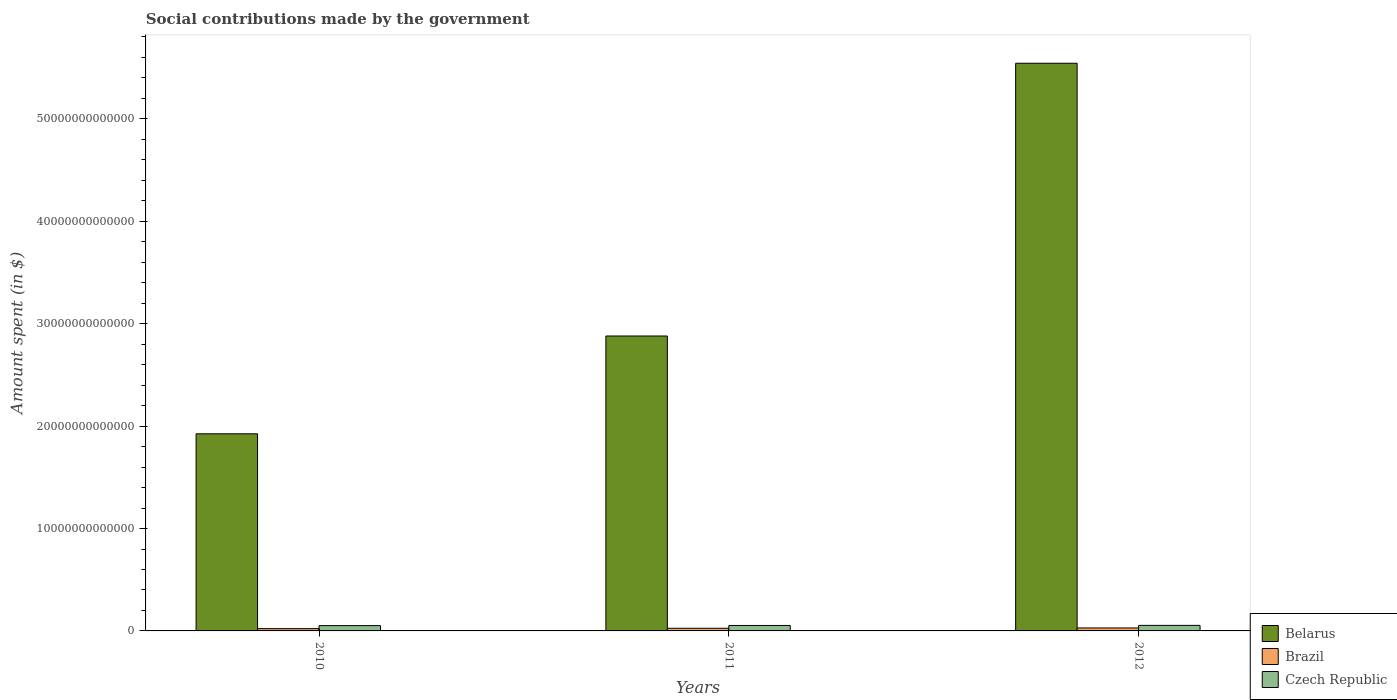How many different coloured bars are there?
Provide a succinct answer. 3. Are the number of bars per tick equal to the number of legend labels?
Keep it short and to the point. Yes. How many bars are there on the 3rd tick from the right?
Give a very brief answer. 3. What is the label of the 3rd group of bars from the left?
Offer a terse response. 2012. In how many cases, is the number of bars for a given year not equal to the number of legend labels?
Your answer should be very brief. 0. What is the amount spent on social contributions in Czech Republic in 2010?
Keep it short and to the point. 5.17e+11. Across all years, what is the maximum amount spent on social contributions in Brazil?
Your answer should be compact. 2.89e+11. Across all years, what is the minimum amount spent on social contributions in Brazil?
Provide a short and direct response. 2.24e+11. In which year was the amount spent on social contributions in Czech Republic minimum?
Offer a very short reply. 2010. What is the total amount spent on social contributions in Czech Republic in the graph?
Offer a terse response. 1.59e+12. What is the difference between the amount spent on social contributions in Belarus in 2010 and that in 2012?
Give a very brief answer. -3.62e+13. What is the difference between the amount spent on social contributions in Czech Republic in 2011 and the amount spent on social contributions in Brazil in 2012?
Provide a succinct answer. 2.44e+11. What is the average amount spent on social contributions in Brazil per year?
Provide a succinct answer. 2.58e+11. In the year 2012, what is the difference between the amount spent on social contributions in Brazil and amount spent on social contributions in Belarus?
Make the answer very short. -5.51e+13. In how many years, is the amount spent on social contributions in Brazil greater than 12000000000000 $?
Your answer should be compact. 0. What is the ratio of the amount spent on social contributions in Brazil in 2010 to that in 2012?
Ensure brevity in your answer.  0.77. What is the difference between the highest and the second highest amount spent on social contributions in Belarus?
Make the answer very short. 2.66e+13. What is the difference between the highest and the lowest amount spent on social contributions in Brazil?
Offer a terse response. 6.52e+1. In how many years, is the amount spent on social contributions in Brazil greater than the average amount spent on social contributions in Brazil taken over all years?
Provide a short and direct response. 2. Is the sum of the amount spent on social contributions in Brazil in 2010 and 2011 greater than the maximum amount spent on social contributions in Czech Republic across all years?
Offer a very short reply. No. What does the 1st bar from the left in 2011 represents?
Offer a terse response. Belarus. How many bars are there?
Your answer should be compact. 9. Are all the bars in the graph horizontal?
Provide a succinct answer. No. What is the difference between two consecutive major ticks on the Y-axis?
Keep it short and to the point. 1.00e+13. Are the values on the major ticks of Y-axis written in scientific E-notation?
Provide a short and direct response. No. Does the graph contain grids?
Your answer should be compact. No. How many legend labels are there?
Your answer should be very brief. 3. How are the legend labels stacked?
Offer a terse response. Vertical. What is the title of the graph?
Provide a succinct answer. Social contributions made by the government. What is the label or title of the Y-axis?
Your response must be concise. Amount spent (in $). What is the Amount spent (in $) in Belarus in 2010?
Your answer should be compact. 1.92e+13. What is the Amount spent (in $) in Brazil in 2010?
Give a very brief answer. 2.24e+11. What is the Amount spent (in $) in Czech Republic in 2010?
Give a very brief answer. 5.17e+11. What is the Amount spent (in $) in Belarus in 2011?
Provide a short and direct response. 2.88e+13. What is the Amount spent (in $) of Brazil in 2011?
Your response must be concise. 2.59e+11. What is the Amount spent (in $) in Czech Republic in 2011?
Provide a short and direct response. 5.33e+11. What is the Amount spent (in $) of Belarus in 2012?
Your answer should be very brief. 5.54e+13. What is the Amount spent (in $) in Brazil in 2012?
Give a very brief answer. 2.89e+11. What is the Amount spent (in $) of Czech Republic in 2012?
Provide a succinct answer. 5.41e+11. Across all years, what is the maximum Amount spent (in $) in Belarus?
Your answer should be very brief. 5.54e+13. Across all years, what is the maximum Amount spent (in $) in Brazil?
Give a very brief answer. 2.89e+11. Across all years, what is the maximum Amount spent (in $) in Czech Republic?
Give a very brief answer. 5.41e+11. Across all years, what is the minimum Amount spent (in $) in Belarus?
Keep it short and to the point. 1.92e+13. Across all years, what is the minimum Amount spent (in $) in Brazil?
Provide a succinct answer. 2.24e+11. Across all years, what is the minimum Amount spent (in $) of Czech Republic?
Make the answer very short. 5.17e+11. What is the total Amount spent (in $) in Belarus in the graph?
Offer a very short reply. 1.03e+14. What is the total Amount spent (in $) in Brazil in the graph?
Provide a short and direct response. 7.73e+11. What is the total Amount spent (in $) of Czech Republic in the graph?
Provide a succinct answer. 1.59e+12. What is the difference between the Amount spent (in $) in Belarus in 2010 and that in 2011?
Your response must be concise. -9.55e+12. What is the difference between the Amount spent (in $) in Brazil in 2010 and that in 2011?
Offer a terse response. -3.50e+1. What is the difference between the Amount spent (in $) in Czech Republic in 2010 and that in 2011?
Ensure brevity in your answer.  -1.57e+1. What is the difference between the Amount spent (in $) of Belarus in 2010 and that in 2012?
Your answer should be very brief. -3.62e+13. What is the difference between the Amount spent (in $) in Brazil in 2010 and that in 2012?
Offer a terse response. -6.52e+1. What is the difference between the Amount spent (in $) of Czech Republic in 2010 and that in 2012?
Give a very brief answer. -2.31e+1. What is the difference between the Amount spent (in $) in Belarus in 2011 and that in 2012?
Provide a short and direct response. -2.66e+13. What is the difference between the Amount spent (in $) in Brazil in 2011 and that in 2012?
Your answer should be very brief. -3.02e+1. What is the difference between the Amount spent (in $) of Czech Republic in 2011 and that in 2012?
Give a very brief answer. -7.46e+09. What is the difference between the Amount spent (in $) of Belarus in 2010 and the Amount spent (in $) of Brazil in 2011?
Your answer should be very brief. 1.90e+13. What is the difference between the Amount spent (in $) of Belarus in 2010 and the Amount spent (in $) of Czech Republic in 2011?
Provide a succinct answer. 1.87e+13. What is the difference between the Amount spent (in $) of Brazil in 2010 and the Amount spent (in $) of Czech Republic in 2011?
Give a very brief answer. -3.09e+11. What is the difference between the Amount spent (in $) of Belarus in 2010 and the Amount spent (in $) of Brazil in 2012?
Ensure brevity in your answer.  1.90e+13. What is the difference between the Amount spent (in $) of Belarus in 2010 and the Amount spent (in $) of Czech Republic in 2012?
Keep it short and to the point. 1.87e+13. What is the difference between the Amount spent (in $) of Brazil in 2010 and the Amount spent (in $) of Czech Republic in 2012?
Provide a succinct answer. -3.16e+11. What is the difference between the Amount spent (in $) of Belarus in 2011 and the Amount spent (in $) of Brazil in 2012?
Give a very brief answer. 2.85e+13. What is the difference between the Amount spent (in $) of Belarus in 2011 and the Amount spent (in $) of Czech Republic in 2012?
Keep it short and to the point. 2.83e+13. What is the difference between the Amount spent (in $) of Brazil in 2011 and the Amount spent (in $) of Czech Republic in 2012?
Your answer should be compact. -2.81e+11. What is the average Amount spent (in $) in Belarus per year?
Keep it short and to the point. 3.45e+13. What is the average Amount spent (in $) in Brazil per year?
Provide a short and direct response. 2.58e+11. What is the average Amount spent (in $) in Czech Republic per year?
Ensure brevity in your answer.  5.30e+11. In the year 2010, what is the difference between the Amount spent (in $) in Belarus and Amount spent (in $) in Brazil?
Offer a terse response. 1.90e+13. In the year 2010, what is the difference between the Amount spent (in $) of Belarus and Amount spent (in $) of Czech Republic?
Your response must be concise. 1.87e+13. In the year 2010, what is the difference between the Amount spent (in $) of Brazil and Amount spent (in $) of Czech Republic?
Offer a very short reply. -2.93e+11. In the year 2011, what is the difference between the Amount spent (in $) of Belarus and Amount spent (in $) of Brazil?
Offer a very short reply. 2.85e+13. In the year 2011, what is the difference between the Amount spent (in $) in Belarus and Amount spent (in $) in Czech Republic?
Keep it short and to the point. 2.83e+13. In the year 2011, what is the difference between the Amount spent (in $) of Brazil and Amount spent (in $) of Czech Republic?
Your answer should be compact. -2.74e+11. In the year 2012, what is the difference between the Amount spent (in $) of Belarus and Amount spent (in $) of Brazil?
Make the answer very short. 5.51e+13. In the year 2012, what is the difference between the Amount spent (in $) in Belarus and Amount spent (in $) in Czech Republic?
Your answer should be very brief. 5.49e+13. In the year 2012, what is the difference between the Amount spent (in $) of Brazil and Amount spent (in $) of Czech Republic?
Keep it short and to the point. -2.51e+11. What is the ratio of the Amount spent (in $) in Belarus in 2010 to that in 2011?
Make the answer very short. 0.67. What is the ratio of the Amount spent (in $) in Brazil in 2010 to that in 2011?
Give a very brief answer. 0.86. What is the ratio of the Amount spent (in $) in Czech Republic in 2010 to that in 2011?
Ensure brevity in your answer.  0.97. What is the ratio of the Amount spent (in $) of Belarus in 2010 to that in 2012?
Offer a terse response. 0.35. What is the ratio of the Amount spent (in $) in Brazil in 2010 to that in 2012?
Provide a short and direct response. 0.77. What is the ratio of the Amount spent (in $) of Czech Republic in 2010 to that in 2012?
Provide a succinct answer. 0.96. What is the ratio of the Amount spent (in $) of Belarus in 2011 to that in 2012?
Your answer should be very brief. 0.52. What is the ratio of the Amount spent (in $) in Brazil in 2011 to that in 2012?
Provide a short and direct response. 0.9. What is the ratio of the Amount spent (in $) of Czech Republic in 2011 to that in 2012?
Your answer should be very brief. 0.99. What is the difference between the highest and the second highest Amount spent (in $) in Belarus?
Offer a terse response. 2.66e+13. What is the difference between the highest and the second highest Amount spent (in $) of Brazil?
Ensure brevity in your answer.  3.02e+1. What is the difference between the highest and the second highest Amount spent (in $) in Czech Republic?
Ensure brevity in your answer.  7.46e+09. What is the difference between the highest and the lowest Amount spent (in $) of Belarus?
Keep it short and to the point. 3.62e+13. What is the difference between the highest and the lowest Amount spent (in $) in Brazil?
Make the answer very short. 6.52e+1. What is the difference between the highest and the lowest Amount spent (in $) of Czech Republic?
Offer a terse response. 2.31e+1. 